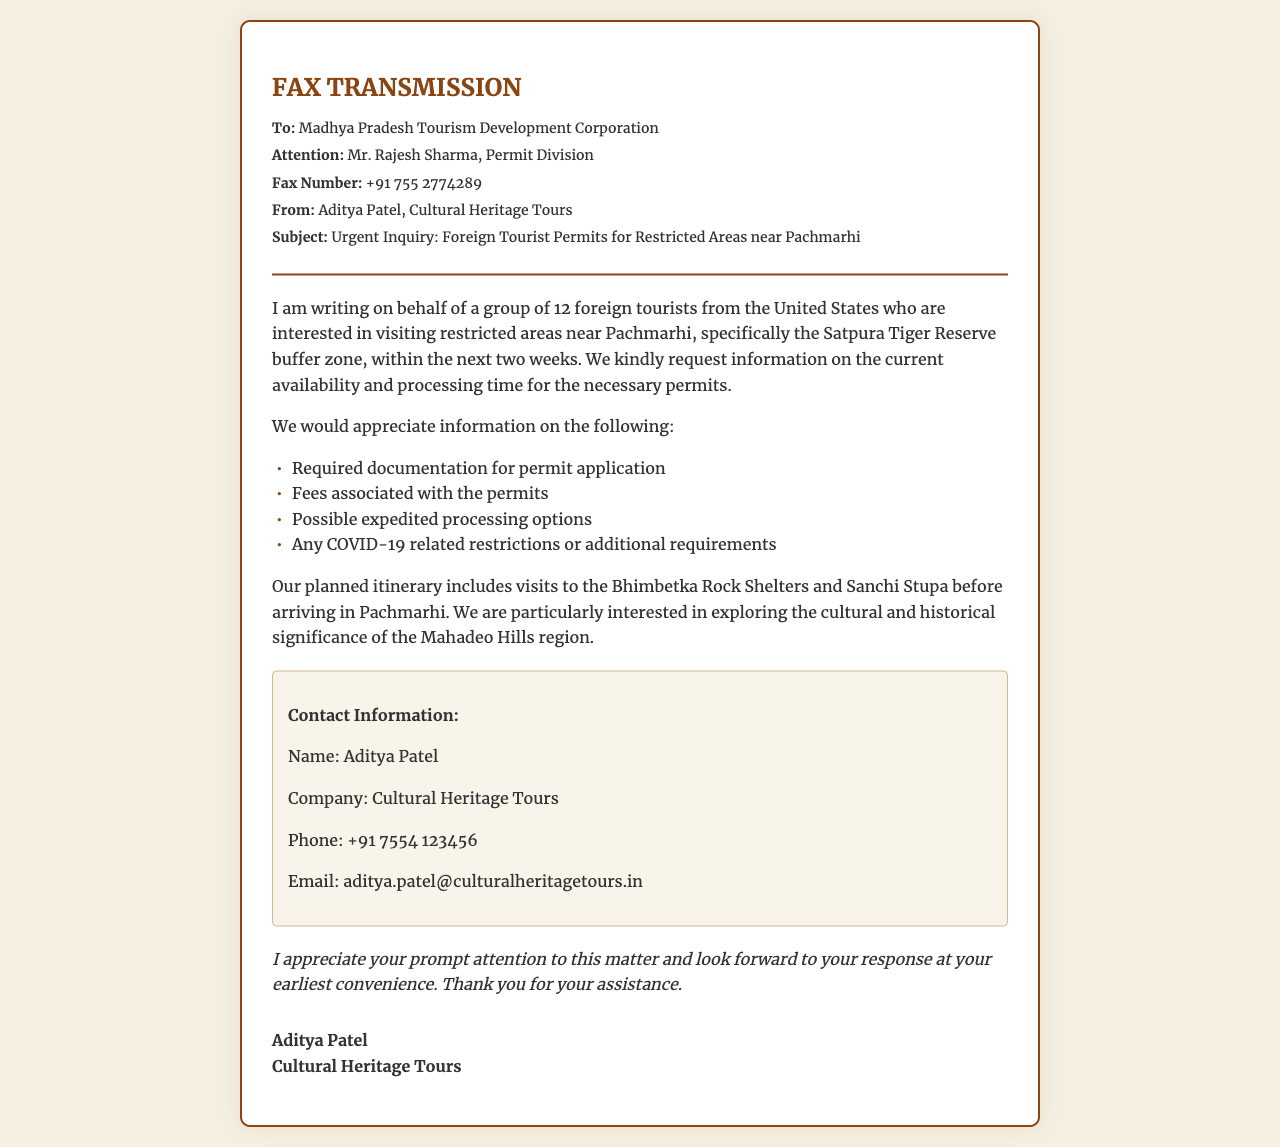What is the subject of the fax? The subject of the fax is specifically requested in the subject line, which states "Urgent Inquiry: Foreign Tourist Permits for Restricted Areas near Pachmarhi."
Answer: Urgent Inquiry: Foreign Tourist Permits for Restricted Areas near Pachmarhi Who is the recipient of the fax? The recipient of the fax is mentioned at the beginning of the document, specifically "To: Madhya Pradesh Tourism Development Corporation."
Answer: Madhya Pradesh Tourism Development Corporation What is the contact email provided in the fax? The contact email for Aditya Patel is included in the contact information section, which states "Email: aditya.patel@culturalheritagetours.in."
Answer: aditya.patel@culturalheritagetours.in How many foreign tourists are mentioned in the inquiry? The document states the group consists of "12 foreign tourists from the United States," which directly answers the question.
Answer: 12 What is one of the locations included in the planned itinerary? The planned itinerary references specific locations, including "Bhimbetka Rock Shelters," that are to be visited before arriving in Pachmarhi.
Answer: Bhimbetka Rock Shelters What type of permits is being inquired about? The fax discusses permits specifically needed for "restricted areas near Pachmarhi," focusing on available permits for visiting these areas.
Answer: permits for restricted areas near Pachmarhi What are two pieces of required information requested for permit applications? The document lists several inquiries, two of which are "Required documentation for permit application" and "Fees associated with the permits."
Answer: Required documentation for permit application, Fees associated with the permits What is the fax number provided in the document? The fax number for contacting the Madhya Pradesh Tourism Development Corporation is clearly stated as "+91 755 2774289."
Answer: +91 755 2774289 